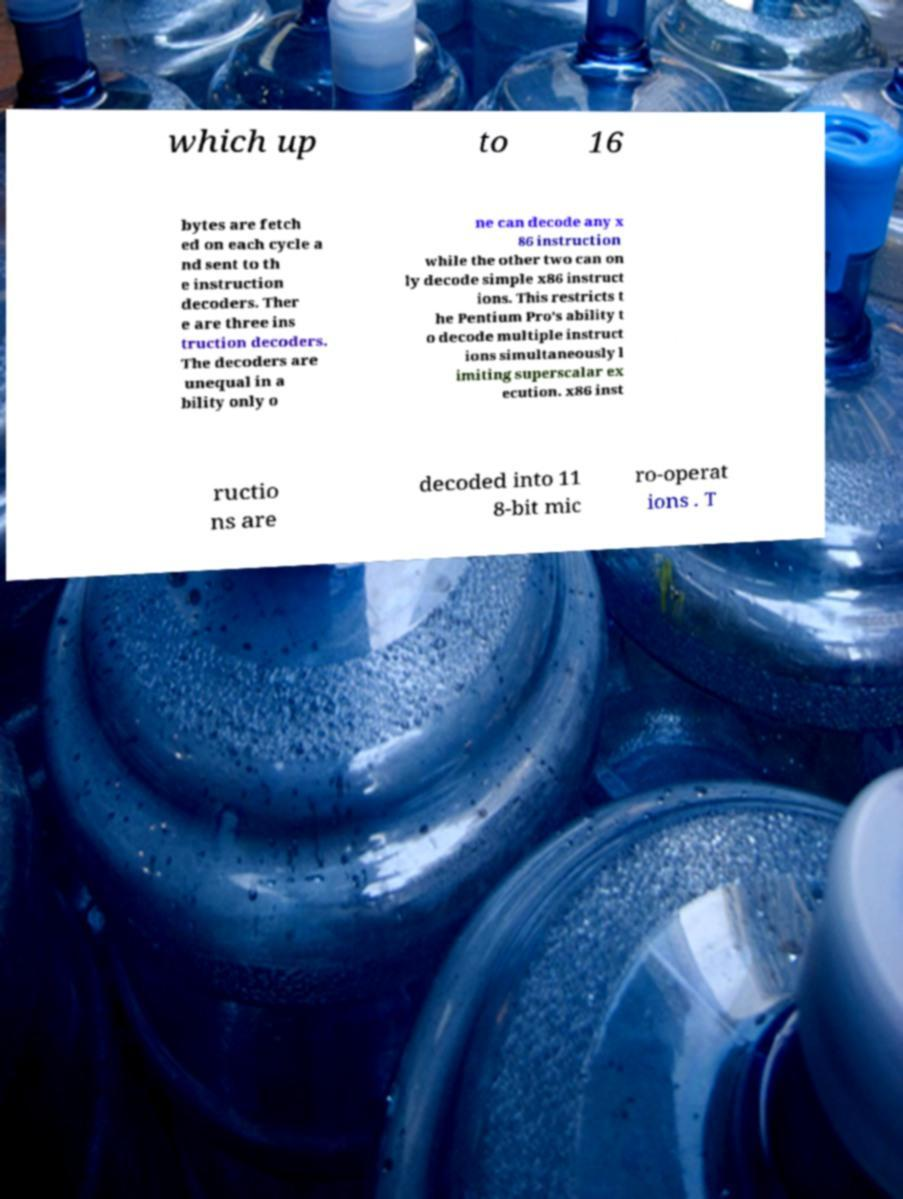What messages or text are displayed in this image? I need them in a readable, typed format. which up to 16 bytes are fetch ed on each cycle a nd sent to th e instruction decoders. Ther e are three ins truction decoders. The decoders are unequal in a bility only o ne can decode any x 86 instruction while the other two can on ly decode simple x86 instruct ions. This restricts t he Pentium Pro's ability t o decode multiple instruct ions simultaneously l imiting superscalar ex ecution. x86 inst ructio ns are decoded into 11 8-bit mic ro-operat ions . T 